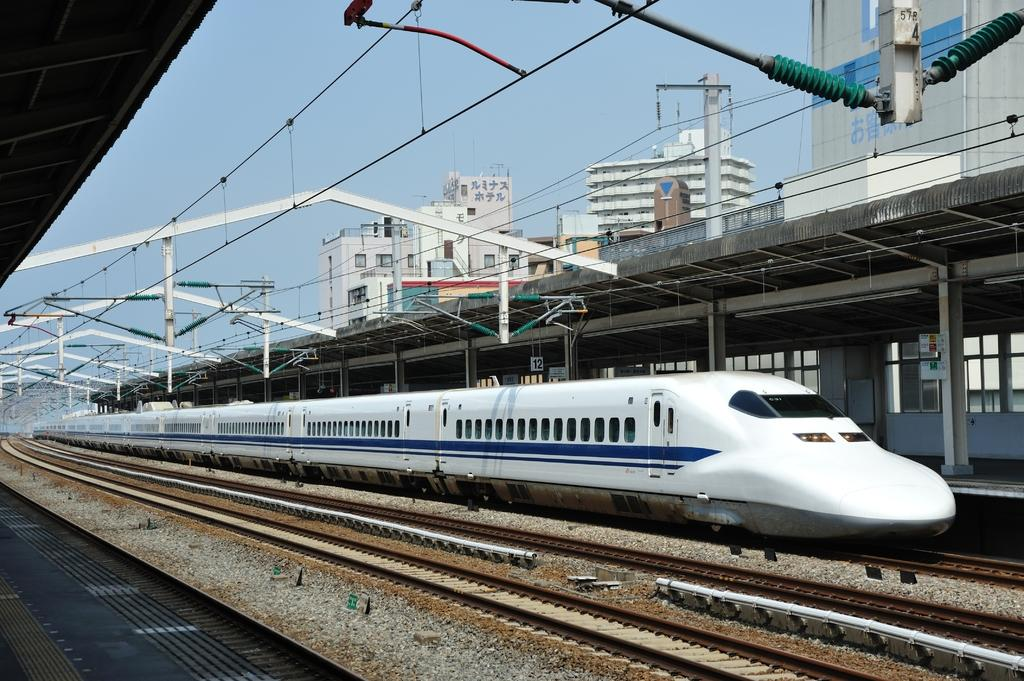What is the color of the train in the image? The train in the image is white. What is located on either side of the train? There are platforms on either side of the train. What can be seen above the train? There are poles and wires above the train. What is visible in the background of the image? There are buildings in the background. How many pigs are present on the train in the image? There are no pigs present on the train in the image. What type of list is being used to organize the train's schedule? There is no list present in the image, and the train's schedule is not mentioned. 